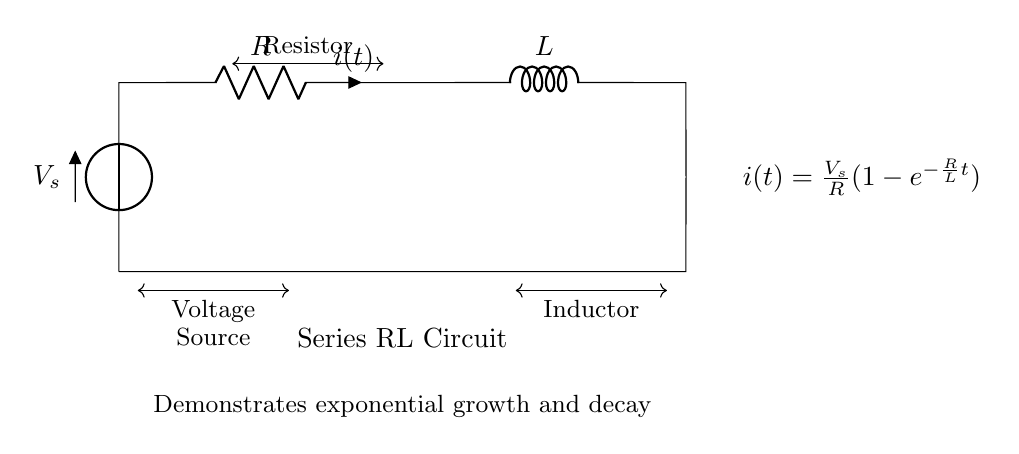What is the type of circuit represented? The circuit depicted is a series Resistor-Inductor circuit, which is differentiated by the arrangement of the resistor and inductor in a single loop.
Answer: Series Resistor-Inductor What does the symbol "V" represent in the circuit? The symbol "V" represents the voltage source, indicating the source of electrical energy in the circuit.
Answer: Voltage source What are the components of this circuit? The circuit contains a resistor and an inductor, which are key components. The resistor limits the current while the inductor stores energy in a magnetic field.
Answer: Resistor, Inductor What is the current formula provided in the circuit? The formula shown is for current as a function of time in the circuit, given by i(t) = V_s / R (1 - e^(-R/L t)), representing the behavior over time as the inductor builds current.
Answer: i(t) = V_s/R(1-e^(-R/L t)) What does the term "exponential growth and decay" refer to in this circuit? This term refers to the behavior of the current flowing through the circuit over time; it exponentially approaches a maximum value as the circuit stabilizes or exponentially decreases when the circuit is de-energized.
Answer: Behavior of current How does the resistance value affect the time constant of the circuit? The resistance determines the time constant τ (tau) of the circuit, which is calculated as τ = L/R. A higher resistance results in a smaller time constant, leading to a quicker response in current change.
Answer: Time constant is L/R What will happen to the current when the voltage source is turned off? When the voltage source is turned off, the current in the circuit will decay exponentially towards zero as the inductor releases its stored energy.
Answer: Current decays to zero 